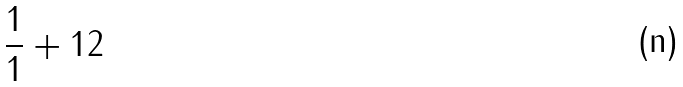Convert formula to latex. <formula><loc_0><loc_0><loc_500><loc_500>\frac { 1 } { 1 } + 1 2</formula> 